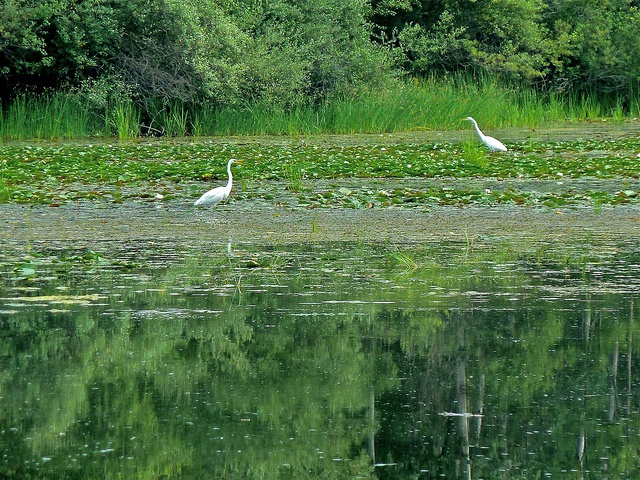Describe the objects in this image and their specific colors. I can see bird in black, white, darkgray, lightblue, and teal tones and bird in black, white, lightblue, darkgray, and green tones in this image. 